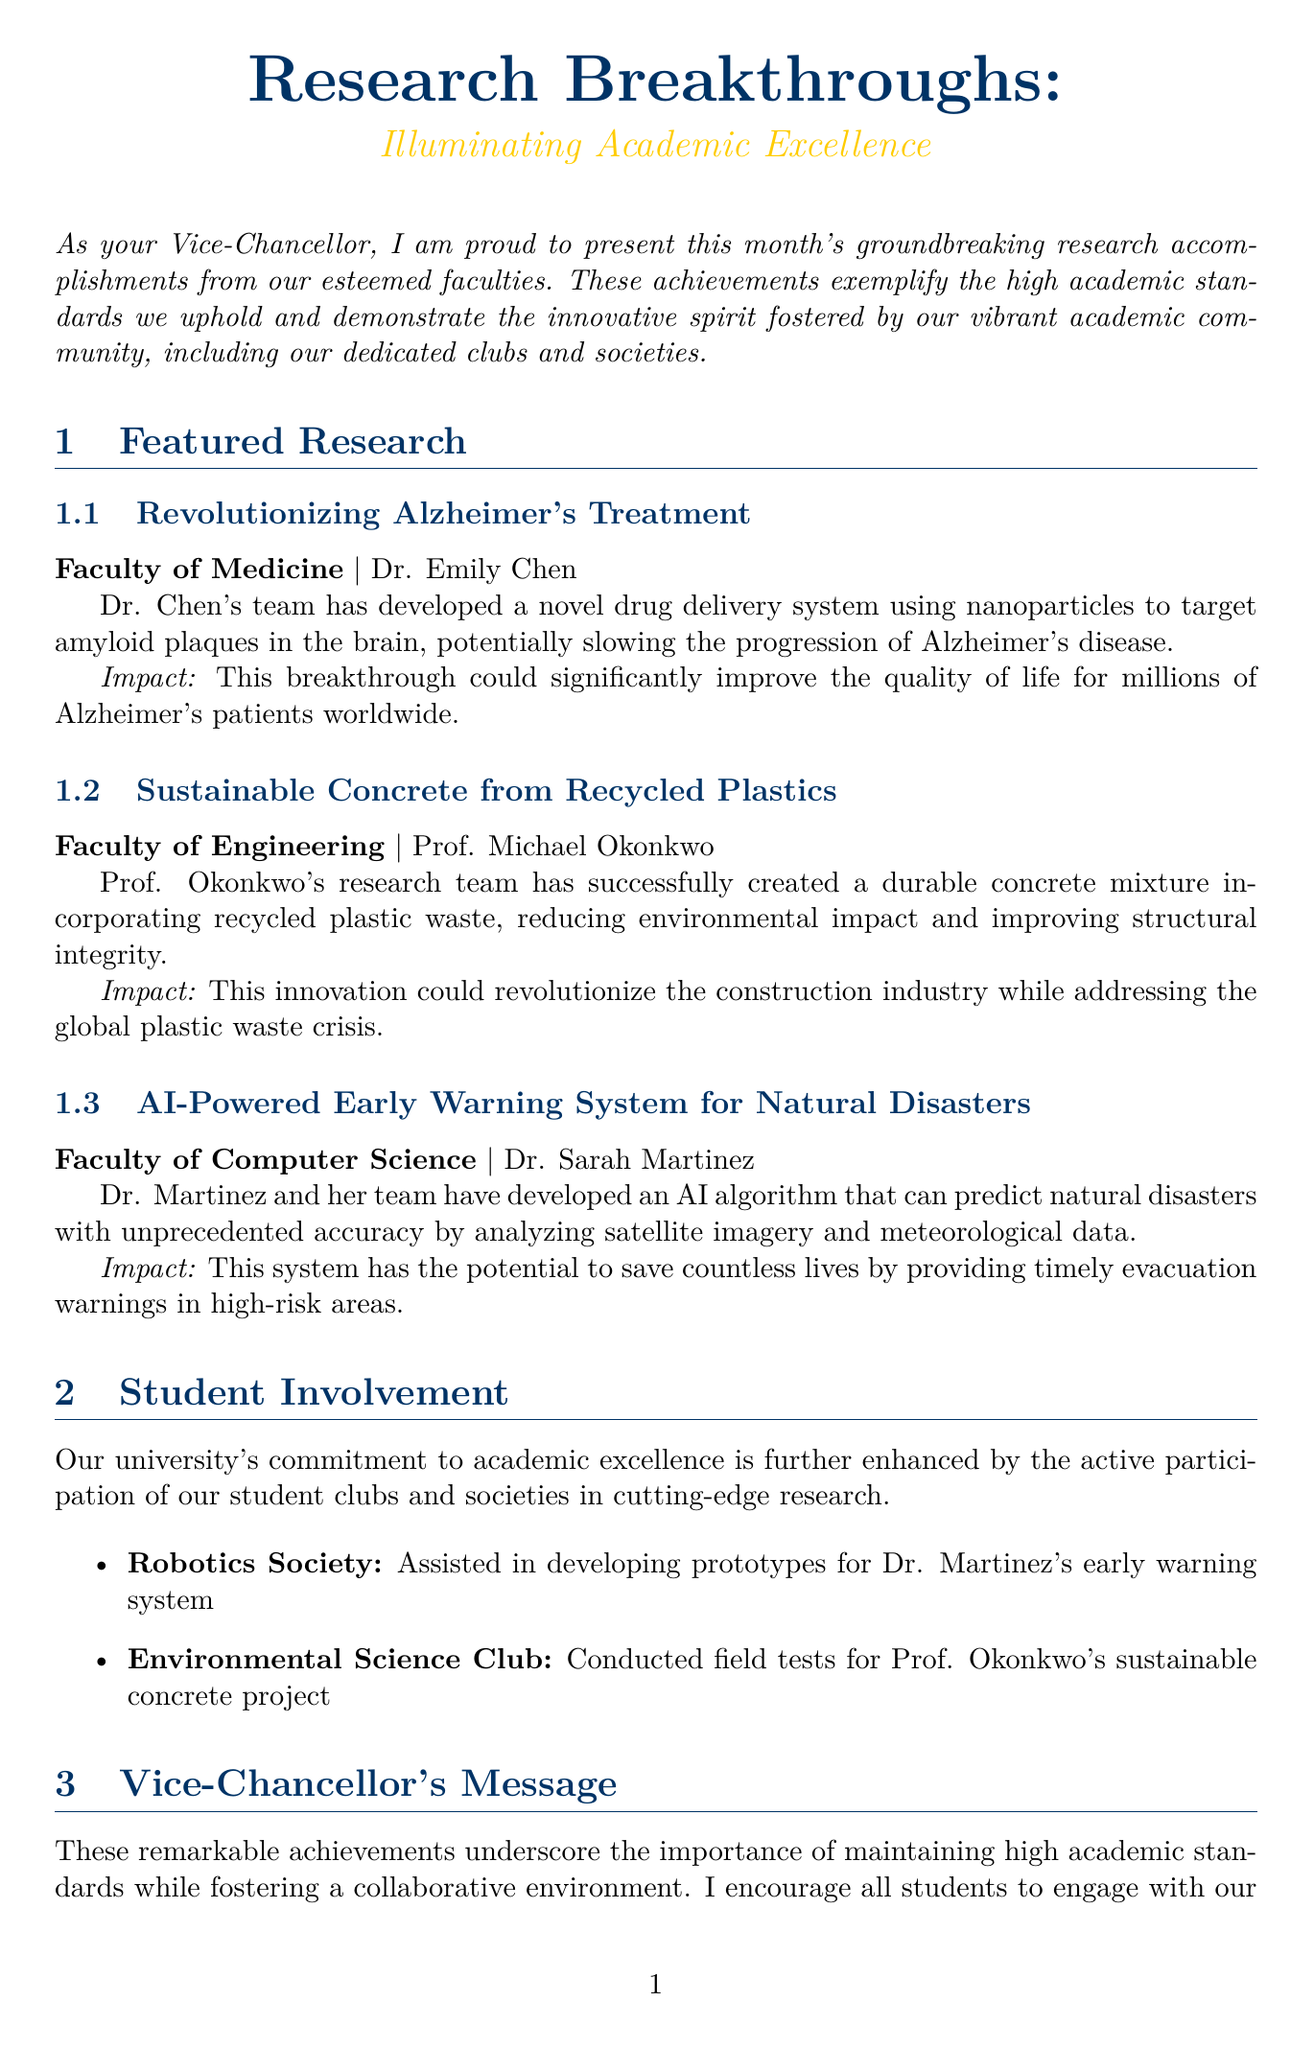What is the title of the newsletter? The title of the newsletter is presented at the start of the document.
Answer: Research Breakthroughs: Illuminating Academic Excellence Who is the researcher for the Alzheimer's treatment? The document lists Dr. Emily Chen as the researcher associated with the Alzheimer's treatment.
Answer: Dr. Emily Chen What innovative material was used in the concrete developed by Prof. Okonkwo? The document explains that Prof. Okonkwo's concrete incorporates recycled plastic waste.
Answer: Recycled plastics What is the date of the Annual Research Symposium? The document specifies the date for the Annual Research Symposium is November 15-17, 2023.
Answer: November 15-17, 2023 Which club assisted in developing prototypes for the AI early warning system? The Robotics Society is mentioned as assisting with the development of prototypes for Dr. Martinez's system.
Answer: Robotics Society What potential impact does the AI-powered system have? The document states that the system has the potential to save countless lives.
Answer: Save countless lives How many research projects are featured in the newsletter? The document provides summaries for three distinct research projects.
Answer: Three Who is the Vice-Chancellor of the university? The introduction mentions that the author is the Vice-Chancellor, but does not specify a name; it can be inferred as 'your Vice-Chancellor'.
Answer: Your Vice-Chancellor What type of event is the Interdisciplinary Innovation Challenge? The document describes the event as a competition for proposing solutions to real-world problems.
Answer: Competition 